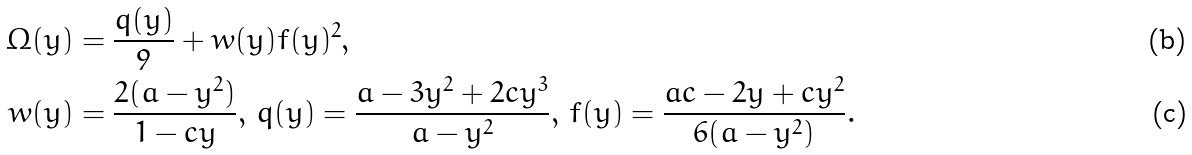<formula> <loc_0><loc_0><loc_500><loc_500>\Omega ( y ) & = \frac { q ( y ) } { 9 } + w ( y ) f ( y ) ^ { 2 } , \\ w ( y ) & = \frac { 2 ( a - y ^ { 2 } ) } { 1 - c y } , \, q ( y ) = \frac { a - 3 y ^ { 2 } + 2 c y ^ { 3 } } { a - y ^ { 2 } } , \, f ( y ) = \frac { a c - 2 y + c y ^ { 2 } } { 6 ( a - y ^ { 2 } ) } .</formula> 